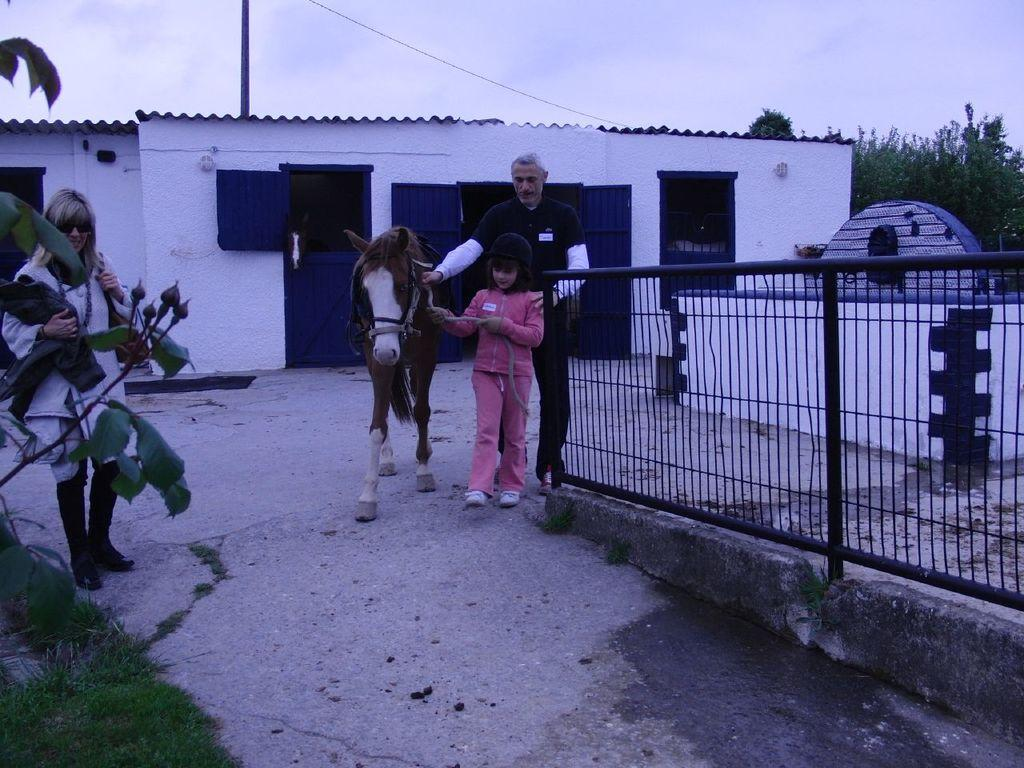Who is present in the image? There is a man, a girl, and a woman in the image. What are the man and girl doing in the image? The man and girl are holding a horse and walking with it. What can be seen in the background of the image? There is a house and trees around it in the background. How many books are stacked on the key in the image? There are no books or keys present in the image. 